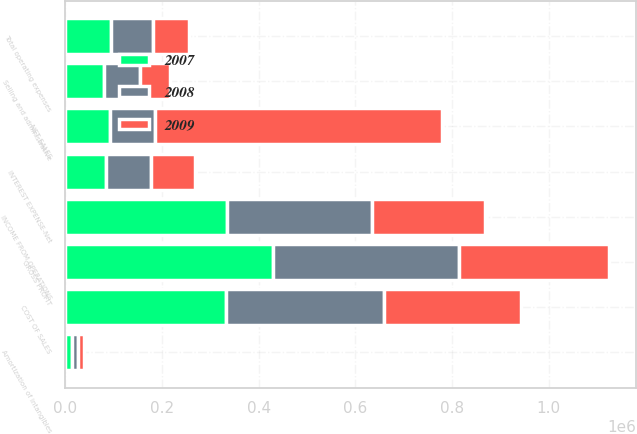Convert chart. <chart><loc_0><loc_0><loc_500><loc_500><stacked_bar_chart><ecel><fcel>NET SALES<fcel>COST OF SALES<fcel>GROSS PROFIT<fcel>Selling and administrative<fcel>Amortization of intangibles<fcel>Total operating expenses<fcel>INCOME FROM OPERATIONS<fcel>INTEREST EXPENSE-Net<nl><fcel>2007<fcel>93311.5<fcel>332206<fcel>429346<fcel>80018<fcel>13928<fcel>93946<fcel>335400<fcel>84398<nl><fcel>2008<fcel>93311.5<fcel>327780<fcel>385931<fcel>74650<fcel>12002<fcel>86652<fcel>299279<fcel>92677<nl><fcel>2009<fcel>592798<fcel>283766<fcel>309032<fcel>62890<fcel>12304<fcel>75194<fcel>233838<fcel>91767<nl></chart> 